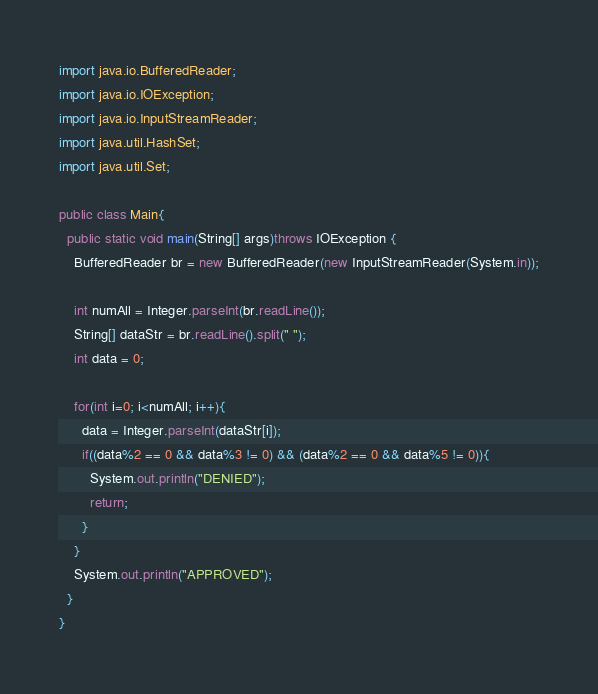<code> <loc_0><loc_0><loc_500><loc_500><_Java_>import java.io.BufferedReader;
import java.io.IOException;
import java.io.InputStreamReader;
import java.util.HashSet;
import java.util.Set;

public class Main{
  public static void main(String[] args)throws IOException {
    BufferedReader br = new BufferedReader(new InputStreamReader(System.in));
    
    int numAll = Integer.parseInt(br.readLine());
    String[] dataStr = br.readLine().split(" ");
    int data = 0;
    
    for(int i=0; i<numAll; i++){
      data = Integer.parseInt(dataStr[i]);
      if((data%2 == 0 && data%3 != 0) && (data%2 == 0 && data%5 != 0)){
        System.out.println("DENIED");
        return;
      }
    }
    System.out.println("APPROVED");
  }
}</code> 